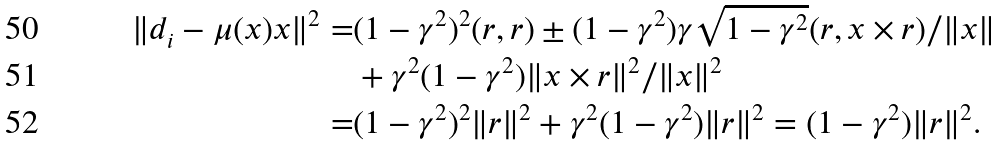<formula> <loc_0><loc_0><loc_500><loc_500>\| d _ { i } - \mu ( x ) x \| ^ { 2 } = & ( 1 - \gamma ^ { 2 } ) ^ { 2 } ( r , r ) \pm ( 1 - \gamma ^ { 2 } ) \gamma \sqrt { 1 - \gamma ^ { 2 } } ( r , x \times r ) / \| x \| \\ & + \gamma ^ { 2 } ( 1 - \gamma ^ { 2 } ) \| x \times r \| ^ { 2 } / \| x \| ^ { 2 } \\ = & ( 1 - \gamma ^ { 2 } ) ^ { 2 } \| r \| ^ { 2 } + \gamma ^ { 2 } ( 1 - \gamma ^ { 2 } ) \| r \| ^ { 2 } = ( 1 - \gamma ^ { 2 } ) \| r \| ^ { 2 } .</formula> 